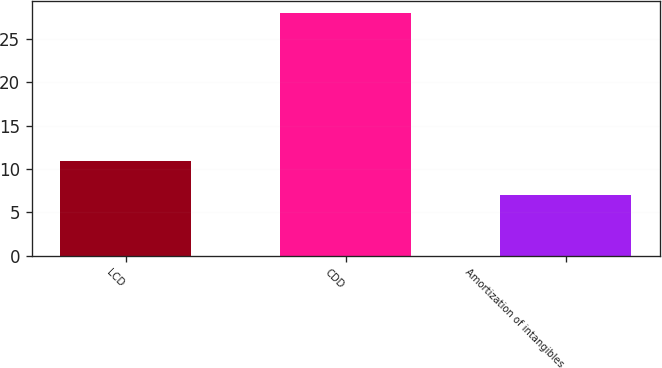<chart> <loc_0><loc_0><loc_500><loc_500><bar_chart><fcel>LCD<fcel>CDD<fcel>Amortization of intangibles<nl><fcel>10.9<fcel>28<fcel>7<nl></chart> 